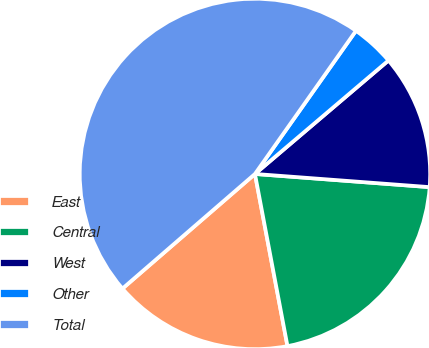Convert chart to OTSL. <chart><loc_0><loc_0><loc_500><loc_500><pie_chart><fcel>East<fcel>Central<fcel>West<fcel>Other<fcel>Total<nl><fcel>16.62%<fcel>20.83%<fcel>12.41%<fcel>4.01%<fcel>46.13%<nl></chart> 